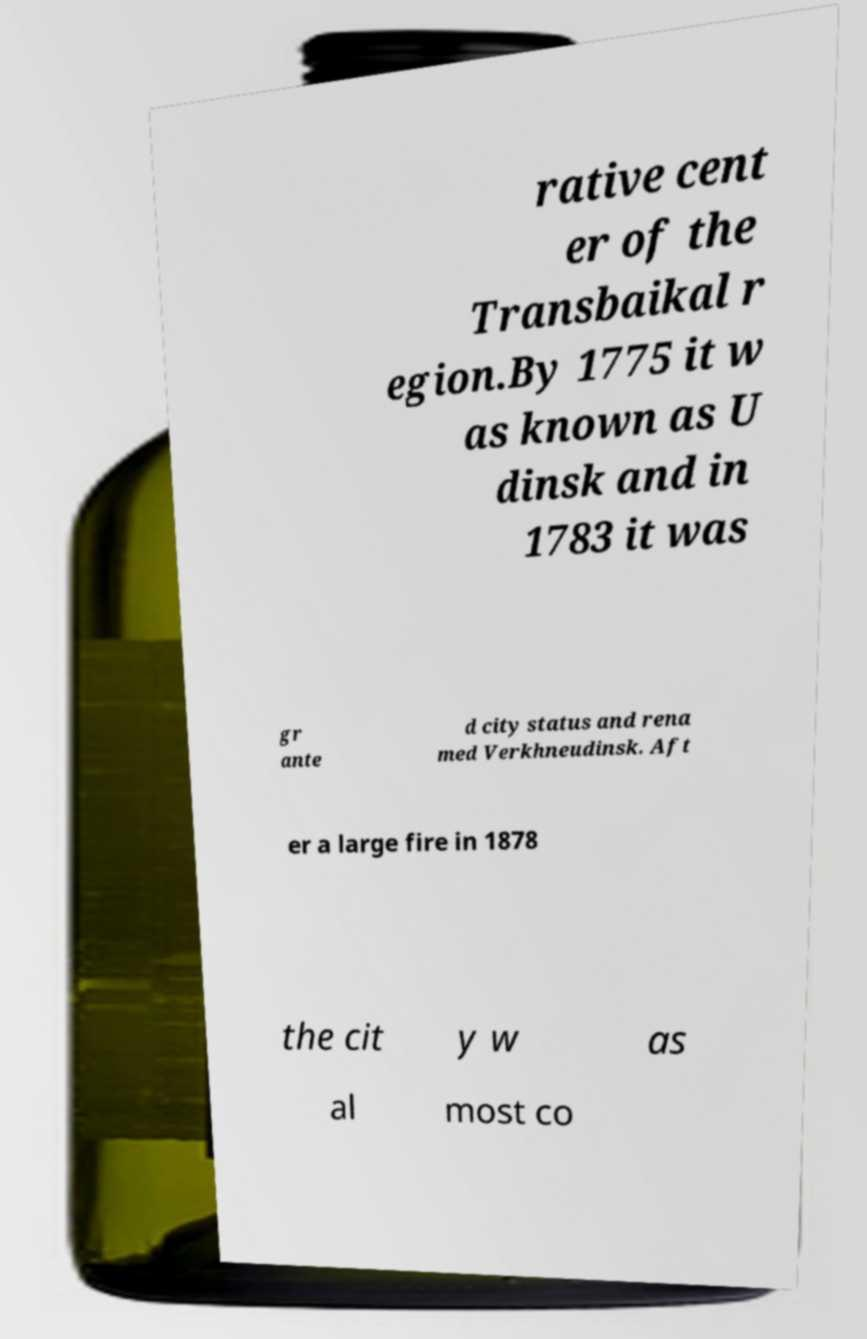What messages or text are displayed in this image? I need them in a readable, typed format. rative cent er of the Transbaikal r egion.By 1775 it w as known as U dinsk and in 1783 it was gr ante d city status and rena med Verkhneudinsk. Aft er a large fire in 1878 the cit y w as al most co 